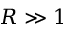Convert formula to latex. <formula><loc_0><loc_0><loc_500><loc_500>R \gg 1</formula> 